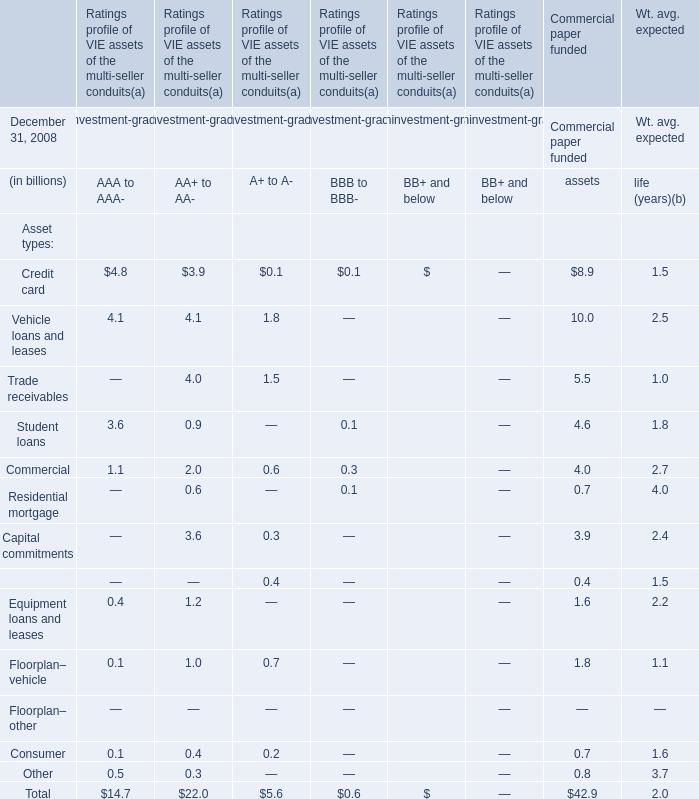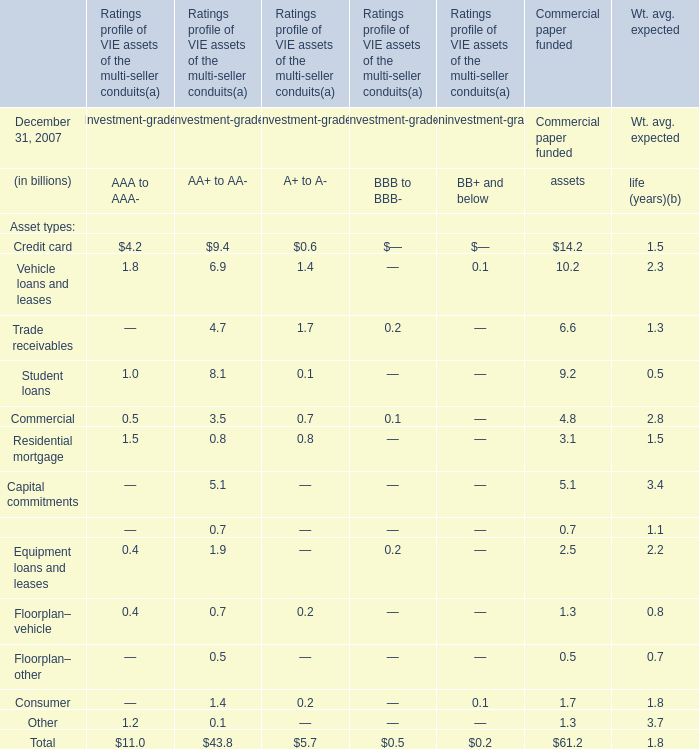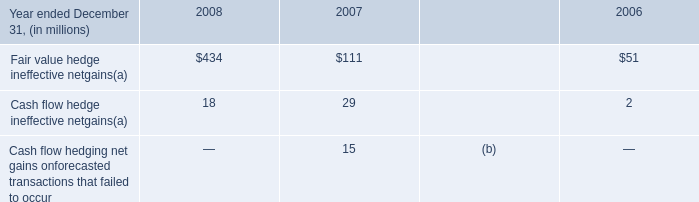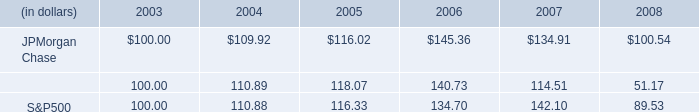What is the value of the Equipment loans and leases For Commercial paper funded assets at December 31, 2007? (in billion) 
Answer: 2.5. 